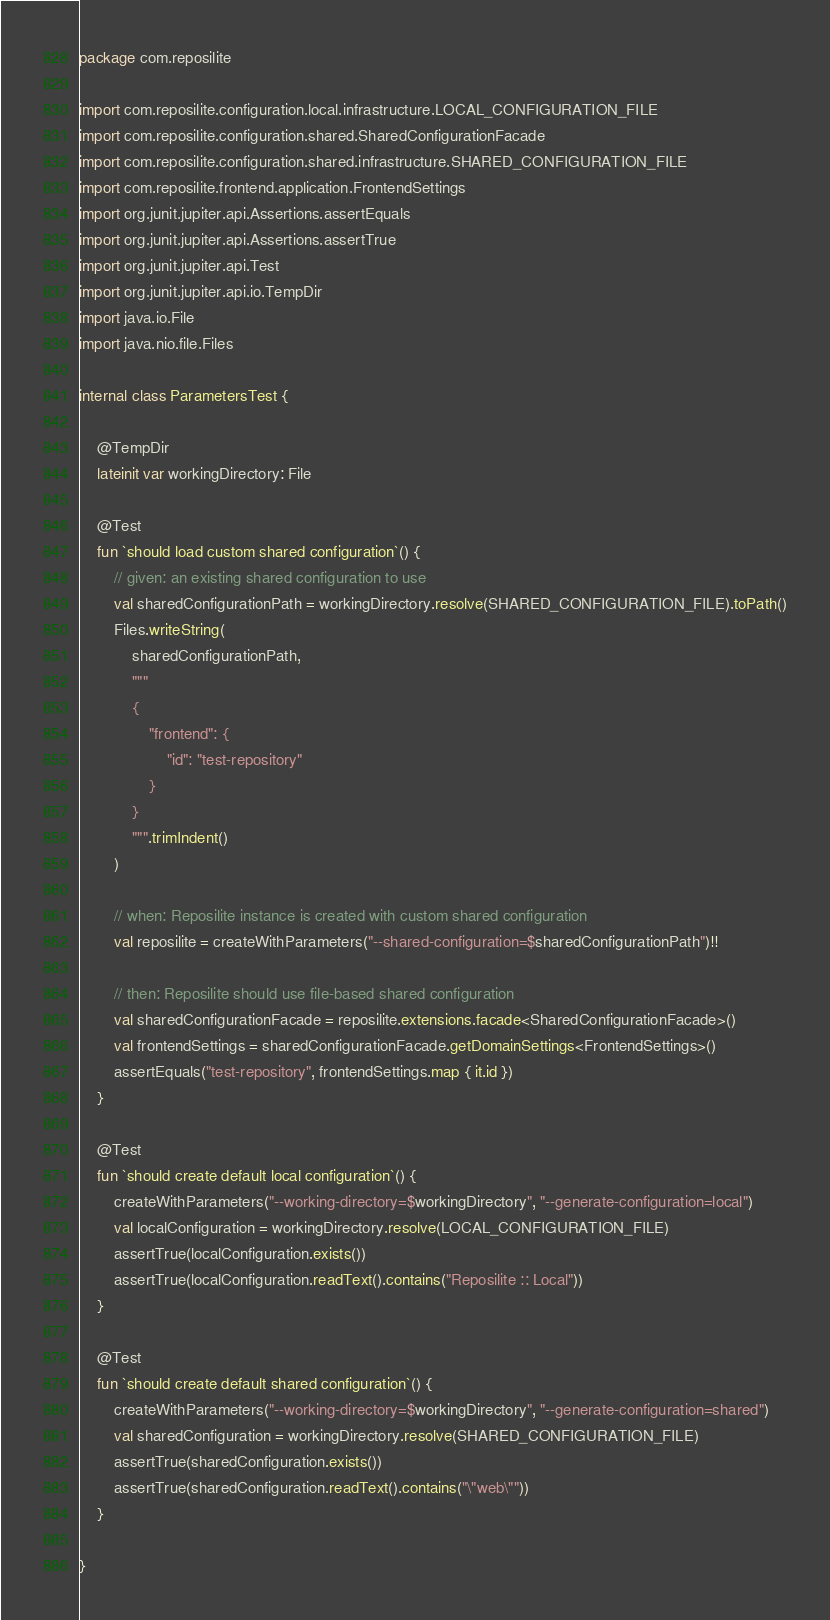<code> <loc_0><loc_0><loc_500><loc_500><_Kotlin_>package com.reposilite

import com.reposilite.configuration.local.infrastructure.LOCAL_CONFIGURATION_FILE
import com.reposilite.configuration.shared.SharedConfigurationFacade
import com.reposilite.configuration.shared.infrastructure.SHARED_CONFIGURATION_FILE
import com.reposilite.frontend.application.FrontendSettings
import org.junit.jupiter.api.Assertions.assertEquals
import org.junit.jupiter.api.Assertions.assertTrue
import org.junit.jupiter.api.Test
import org.junit.jupiter.api.io.TempDir
import java.io.File
import java.nio.file.Files

internal class ParametersTest {

    @TempDir
    lateinit var workingDirectory: File

    @Test
    fun `should load custom shared configuration`() {
        // given: an existing shared configuration to use
        val sharedConfigurationPath = workingDirectory.resolve(SHARED_CONFIGURATION_FILE).toPath()
        Files.writeString(
            sharedConfigurationPath,
            """
            {
                "frontend": {
                    "id": "test-repository"
                }
            }
            """.trimIndent()
        )

        // when: Reposilite instance is created with custom shared configuration
        val reposilite = createWithParameters("--shared-configuration=$sharedConfigurationPath")!!

        // then: Reposilite should use file-based shared configuration
        val sharedConfigurationFacade = reposilite.extensions.facade<SharedConfigurationFacade>()
        val frontendSettings = sharedConfigurationFacade.getDomainSettings<FrontendSettings>()
        assertEquals("test-repository", frontendSettings.map { it.id })
    }

    @Test
    fun `should create default local configuration`() {
        createWithParameters("--working-directory=$workingDirectory", "--generate-configuration=local")
        val localConfiguration = workingDirectory.resolve(LOCAL_CONFIGURATION_FILE)
        assertTrue(localConfiguration.exists())
        assertTrue(localConfiguration.readText().contains("Reposilite :: Local"))
    }

    @Test
    fun `should create default shared configuration`() {
        createWithParameters("--working-directory=$workingDirectory", "--generate-configuration=shared")
        val sharedConfiguration = workingDirectory.resolve(SHARED_CONFIGURATION_FILE)
        assertTrue(sharedConfiguration.exists())
        assertTrue(sharedConfiguration.readText().contains("\"web\""))
    }

}
</code> 